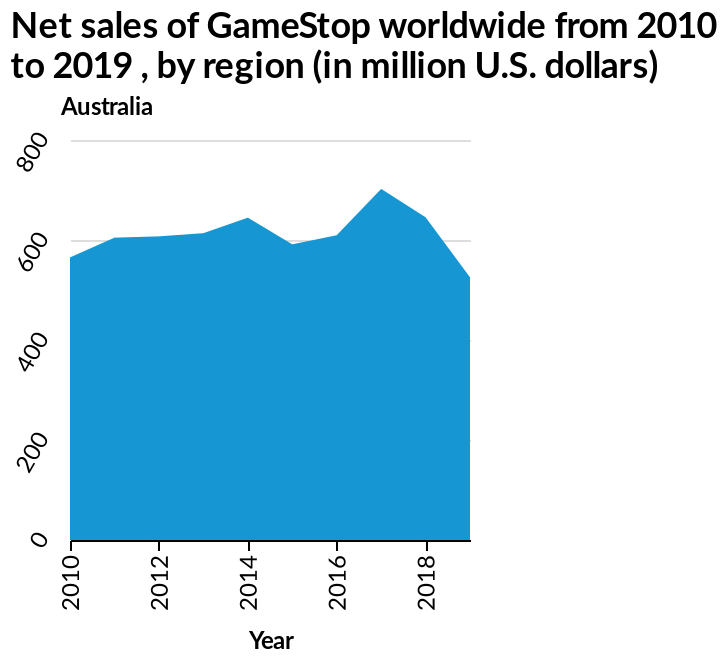<image>
Which region is represented on the y-axis?  The region represented on the y-axis is Australia. What is the unit of measurement for the data plotted on the y-axis? The unit of measurement for the data plotted on the y-axis is million U.S. dollars. 